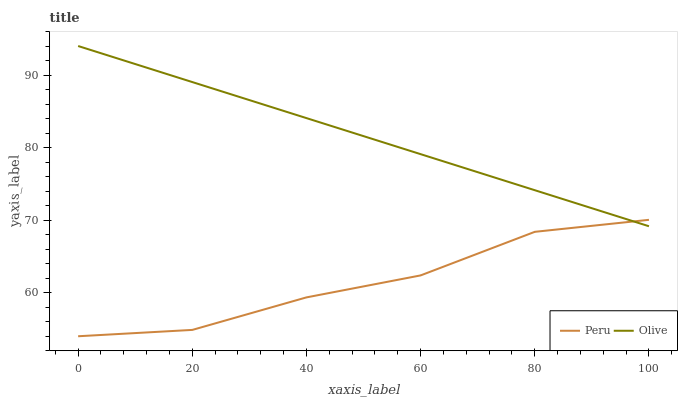Does Peru have the minimum area under the curve?
Answer yes or no. Yes. Does Olive have the maximum area under the curve?
Answer yes or no. Yes. Does Peru have the maximum area under the curve?
Answer yes or no. No. Is Olive the smoothest?
Answer yes or no. Yes. Is Peru the roughest?
Answer yes or no. Yes. Is Peru the smoothest?
Answer yes or no. No. Does Peru have the lowest value?
Answer yes or no. Yes. Does Olive have the highest value?
Answer yes or no. Yes. Does Peru have the highest value?
Answer yes or no. No. Does Peru intersect Olive?
Answer yes or no. Yes. Is Peru less than Olive?
Answer yes or no. No. Is Peru greater than Olive?
Answer yes or no. No. 